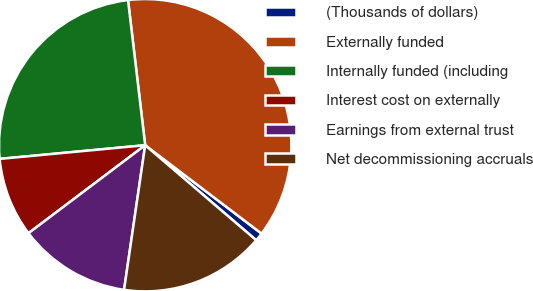Convert chart to OTSL. <chart><loc_0><loc_0><loc_500><loc_500><pie_chart><fcel>(Thousands of dollars)<fcel>Externally funded<fcel>Internally funded (including<fcel>Interest cost on externally<fcel>Earnings from external trust<fcel>Net decommissioning accruals<nl><fcel>0.93%<fcel>37.21%<fcel>24.62%<fcel>8.79%<fcel>12.41%<fcel>16.04%<nl></chart> 